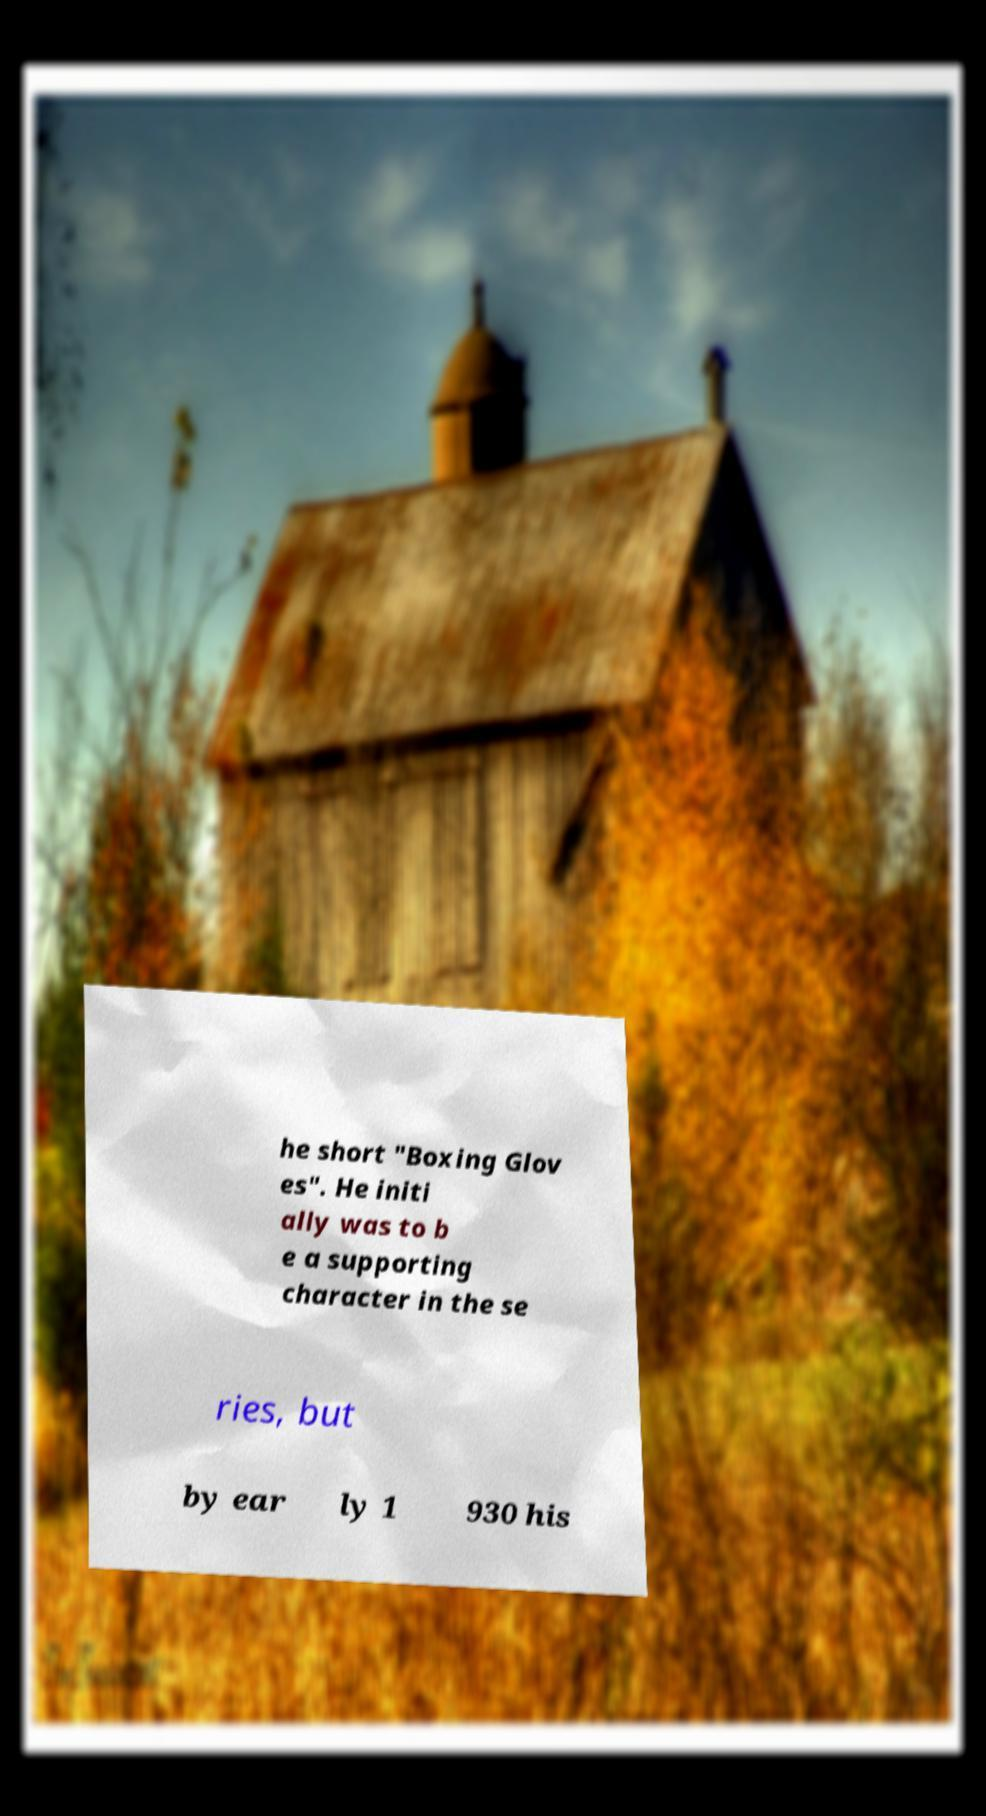Please read and relay the text visible in this image. What does it say? he short "Boxing Glov es". He initi ally was to b e a supporting character in the se ries, but by ear ly 1 930 his 